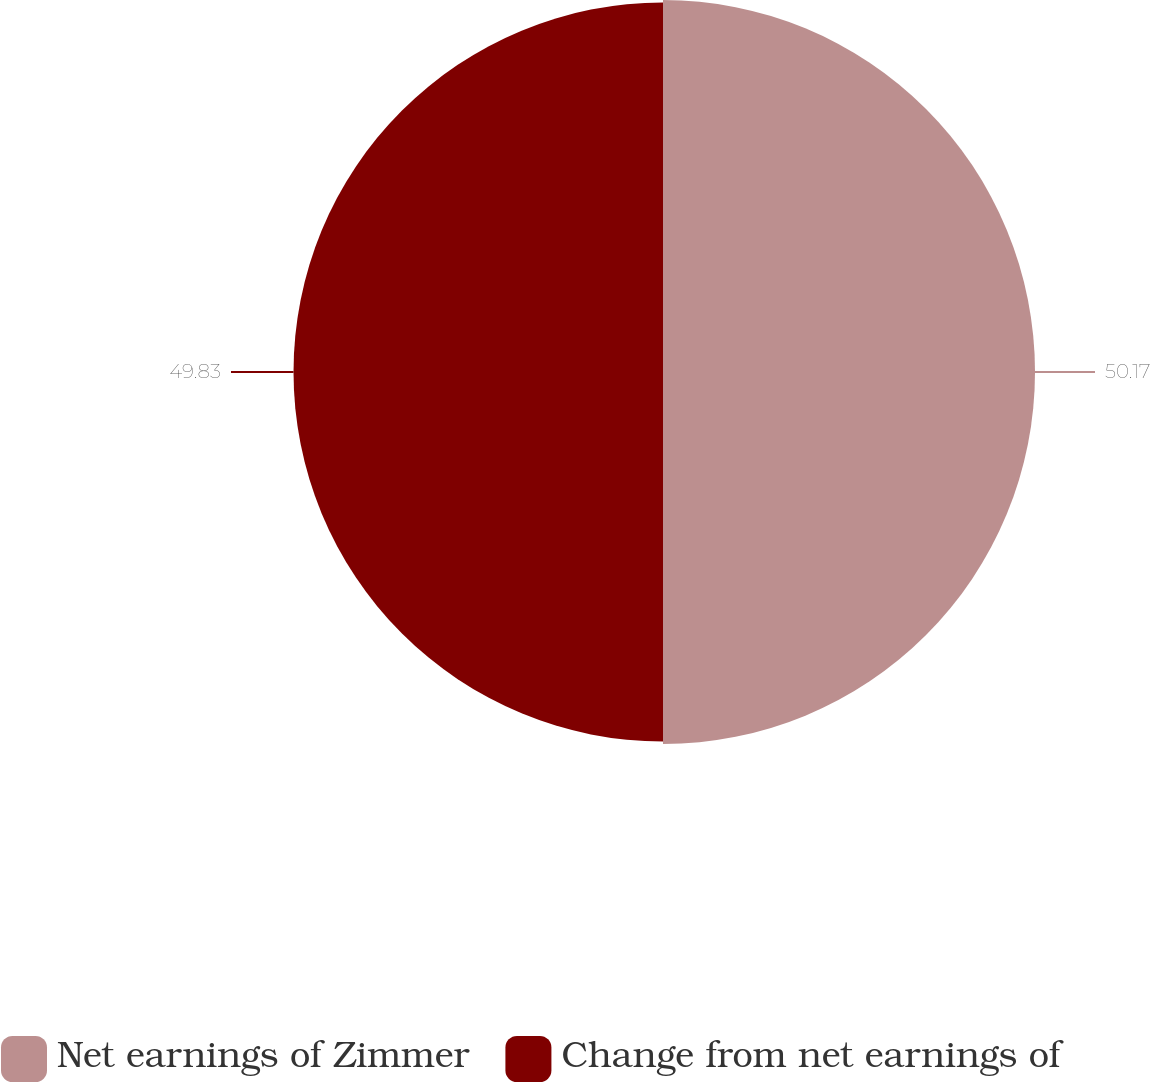<chart> <loc_0><loc_0><loc_500><loc_500><pie_chart><fcel>Net earnings of Zimmer<fcel>Change from net earnings of<nl><fcel>50.17%<fcel>49.83%<nl></chart> 